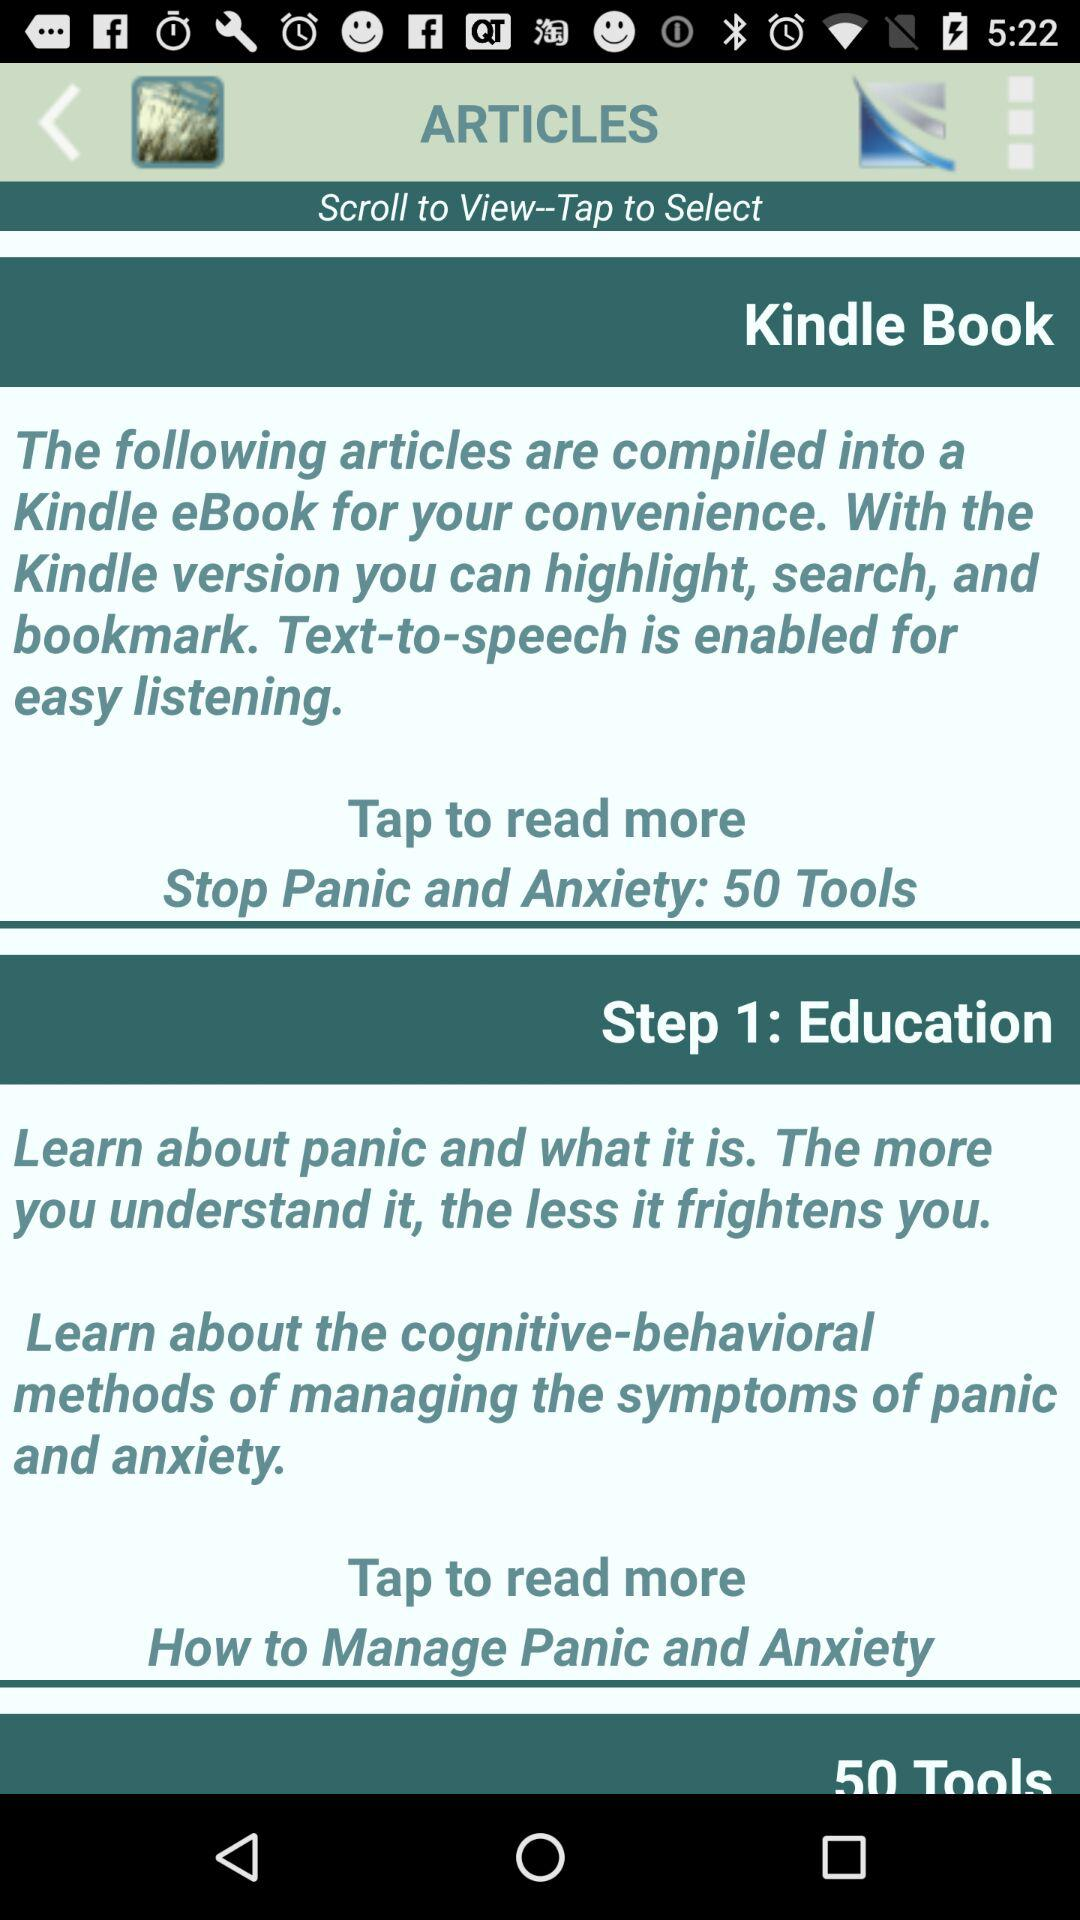What is the name of the application? The name of the application is "Stop Panic & Anxiety Self-Help". 